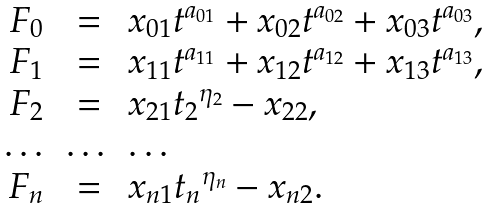Convert formula to latex. <formula><loc_0><loc_0><loc_500><loc_500>\begin{array} { c c l } F _ { 0 } & = & x _ { 0 1 } { t } ^ { a _ { 0 1 } } + x _ { 0 2 } { t } ^ { a _ { 0 2 } } + x _ { 0 3 } { t } ^ { a _ { 0 3 } } , \\ F _ { 1 } & = & x _ { 1 1 } { t } ^ { a _ { 1 1 } } + x _ { 1 2 } { t } ^ { a _ { 1 2 } } + x _ { 1 3 } { t } ^ { a _ { 1 3 } } , \\ F _ { 2 } & = & x _ { 2 1 } { t _ { 2 } } ^ { \eta _ { 2 } } - x _ { 2 2 } , \\ \dots & \dots & \dots \\ F _ { n } & = & x _ { n 1 } { t _ { n } } ^ { \eta _ { n } } - x _ { n 2 } . \end{array}</formula> 